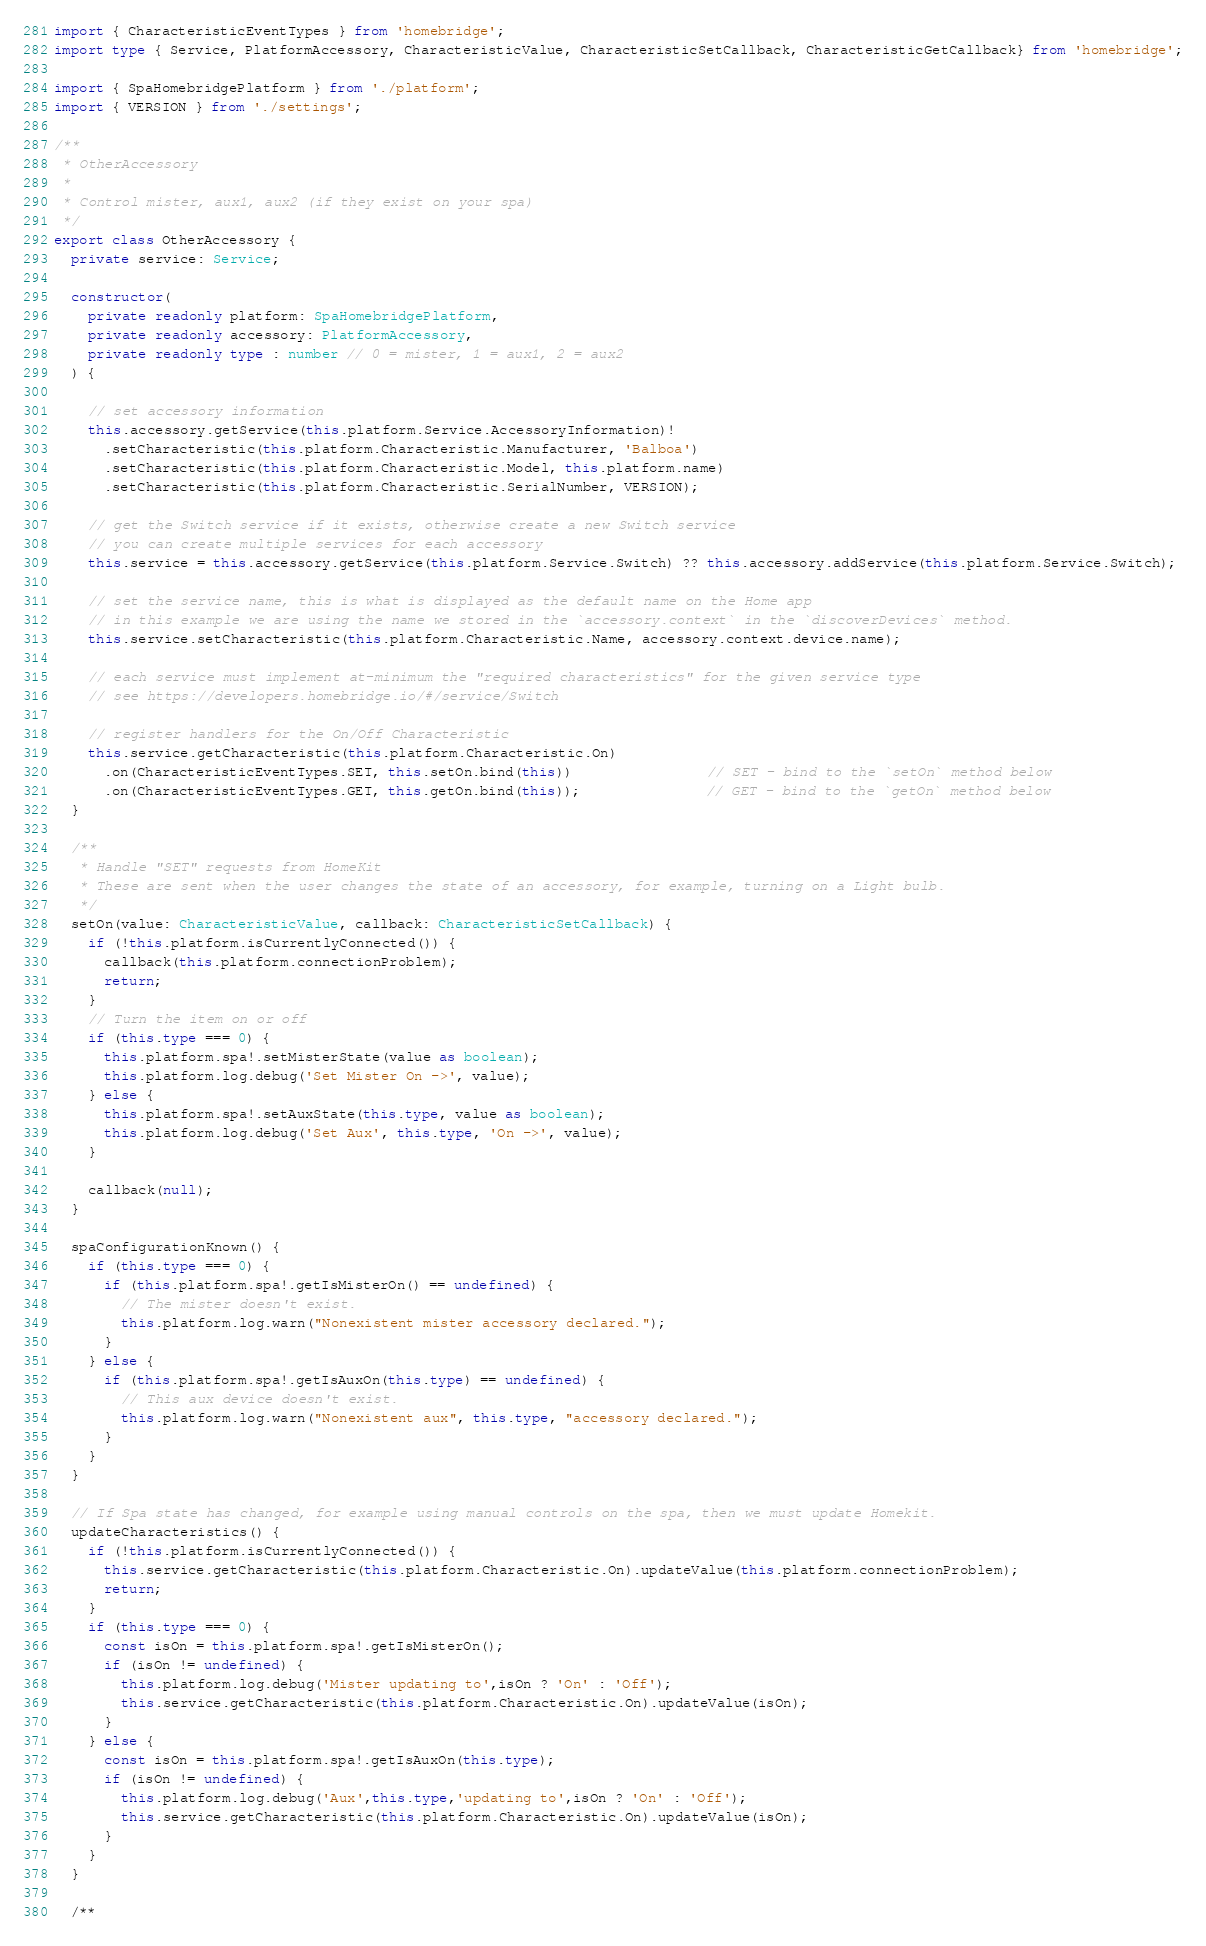Convert code to text. <code><loc_0><loc_0><loc_500><loc_500><_TypeScript_>import { CharacteristicEventTypes } from 'homebridge';
import type { Service, PlatformAccessory, CharacteristicValue, CharacteristicSetCallback, CharacteristicGetCallback} from 'homebridge';

import { SpaHomebridgePlatform } from './platform';
import { VERSION } from './settings';

/**
 * OtherAccessory
 * 
 * Control mister, aux1, aux2 (if they exist on your spa)
 */
export class OtherAccessory {
  private service: Service;

  constructor(
    private readonly platform: SpaHomebridgePlatform,
    private readonly accessory: PlatformAccessory,
    private readonly type : number // 0 = mister, 1 = aux1, 2 = aux2
  ) {

    // set accessory information
    this.accessory.getService(this.platform.Service.AccessoryInformation)!
      .setCharacteristic(this.platform.Characteristic.Manufacturer, 'Balboa')
      .setCharacteristic(this.platform.Characteristic.Model, this.platform.name)
      .setCharacteristic(this.platform.Characteristic.SerialNumber, VERSION);

    // get the Switch service if it exists, otherwise create a new Switch service
    // you can create multiple services for each accessory
    this.service = this.accessory.getService(this.platform.Service.Switch) ?? this.accessory.addService(this.platform.Service.Switch);

    // set the service name, this is what is displayed as the default name on the Home app
    // in this example we are using the name we stored in the `accessory.context` in the `discoverDevices` method.
    this.service.setCharacteristic(this.platform.Characteristic.Name, accessory.context.device.name);

    // each service must implement at-minimum the "required characteristics" for the given service type
    // see https://developers.homebridge.io/#/service/Switch

    // register handlers for the On/Off Characteristic
    this.service.getCharacteristic(this.platform.Characteristic.On)
      .on(CharacteristicEventTypes.SET, this.setOn.bind(this))                // SET - bind to the `setOn` method below
      .on(CharacteristicEventTypes.GET, this.getOn.bind(this));               // GET - bind to the `getOn` method below
  }

  /**
   * Handle "SET" requests from HomeKit
   * These are sent when the user changes the state of an accessory, for example, turning on a Light bulb.
   */
  setOn(value: CharacteristicValue, callback: CharacteristicSetCallback) {
    if (!this.platform.isCurrentlyConnected()) {
      callback(this.platform.connectionProblem);
      return;
    }
    // Turn the item on or off
    if (this.type === 0) {
      this.platform.spa!.setMisterState(value as boolean);
      this.platform.log.debug('Set Mister On ->', value);
    } else {
      this.platform.spa!.setAuxState(this.type, value as boolean);
      this.platform.log.debug('Set Aux', this.type, 'On ->', value);
    }

    callback(null);
  }

  spaConfigurationKnown() {
    if (this.type === 0) {
      if (this.platform.spa!.getIsMisterOn() == undefined) {
        // The mister doesn't exist.
        this.platform.log.warn("Nonexistent mister accessory declared.");
      }
    } else {
      if (this.platform.spa!.getIsAuxOn(this.type) == undefined) {
        // This aux device doesn't exist.
        this.platform.log.warn("Nonexistent aux", this.type, "accessory declared.");
      }
    }
  }

  // If Spa state has changed, for example using manual controls on the spa, then we must update Homekit.
  updateCharacteristics() {
    if (!this.platform.isCurrentlyConnected()) {
      this.service.getCharacteristic(this.platform.Characteristic.On).updateValue(this.platform.connectionProblem);
      return;
    }
    if (this.type === 0) {
      const isOn = this.platform.spa!.getIsMisterOn();
      if (isOn != undefined) {
        this.platform.log.debug('Mister updating to',isOn ? 'On' : 'Off');
        this.service.getCharacteristic(this.platform.Characteristic.On).updateValue(isOn);
      }
    } else {
      const isOn = this.platform.spa!.getIsAuxOn(this.type);
      if (isOn != undefined) {
        this.platform.log.debug('Aux',this.type,'updating to',isOn ? 'On' : 'Off');
        this.service.getCharacteristic(this.platform.Characteristic.On).updateValue(isOn);
      }
    }
  }
  
  /**</code> 